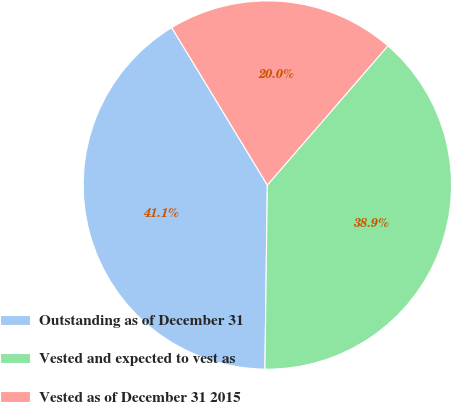<chart> <loc_0><loc_0><loc_500><loc_500><pie_chart><fcel>Outstanding as of December 31<fcel>Vested and expected to vest as<fcel>Vested as of December 31 2015<nl><fcel>41.1%<fcel>38.85%<fcel>20.04%<nl></chart> 